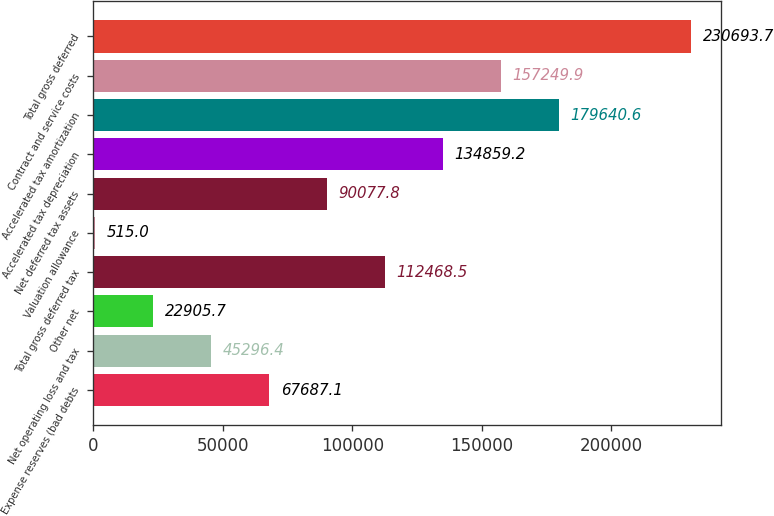Convert chart to OTSL. <chart><loc_0><loc_0><loc_500><loc_500><bar_chart><fcel>Expense reserves (bad debts<fcel>Net operating loss and tax<fcel>Other net<fcel>Total gross deferred tax<fcel>Valuation allowance<fcel>Net deferred tax assets<fcel>Accelerated tax depreciation<fcel>Accelerated tax amortization<fcel>Contract and service costs<fcel>Total gross deferred<nl><fcel>67687.1<fcel>45296.4<fcel>22905.7<fcel>112468<fcel>515<fcel>90077.8<fcel>134859<fcel>179641<fcel>157250<fcel>230694<nl></chart> 